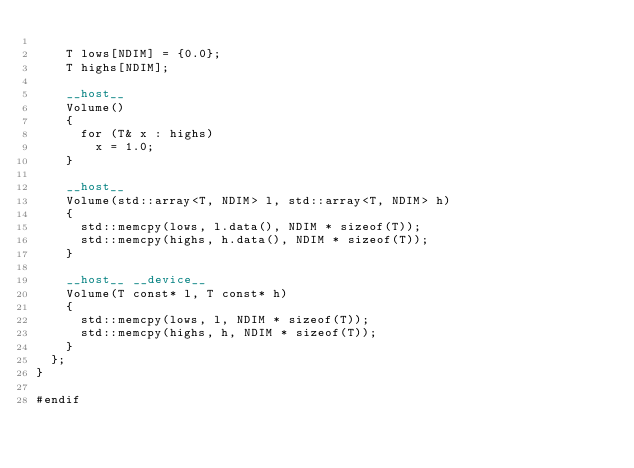<code> <loc_0><loc_0><loc_500><loc_500><_Cuda_>
    T lows[NDIM] = {0.0};
    T highs[NDIM];

    __host__
    Volume()
    {
      for (T& x : highs)
        x = 1.0;
    }

    __host__
    Volume(std::array<T, NDIM> l, std::array<T, NDIM> h)
    {
      std::memcpy(lows, l.data(), NDIM * sizeof(T));
      std::memcpy(highs, h.data(), NDIM * sizeof(T));
    }

    __host__ __device__
    Volume(T const* l, T const* h)
    {
      std::memcpy(lows, l, NDIM * sizeof(T));
      std::memcpy(highs, h, NDIM * sizeof(T));
    }
  };
}

#endif
</code> 